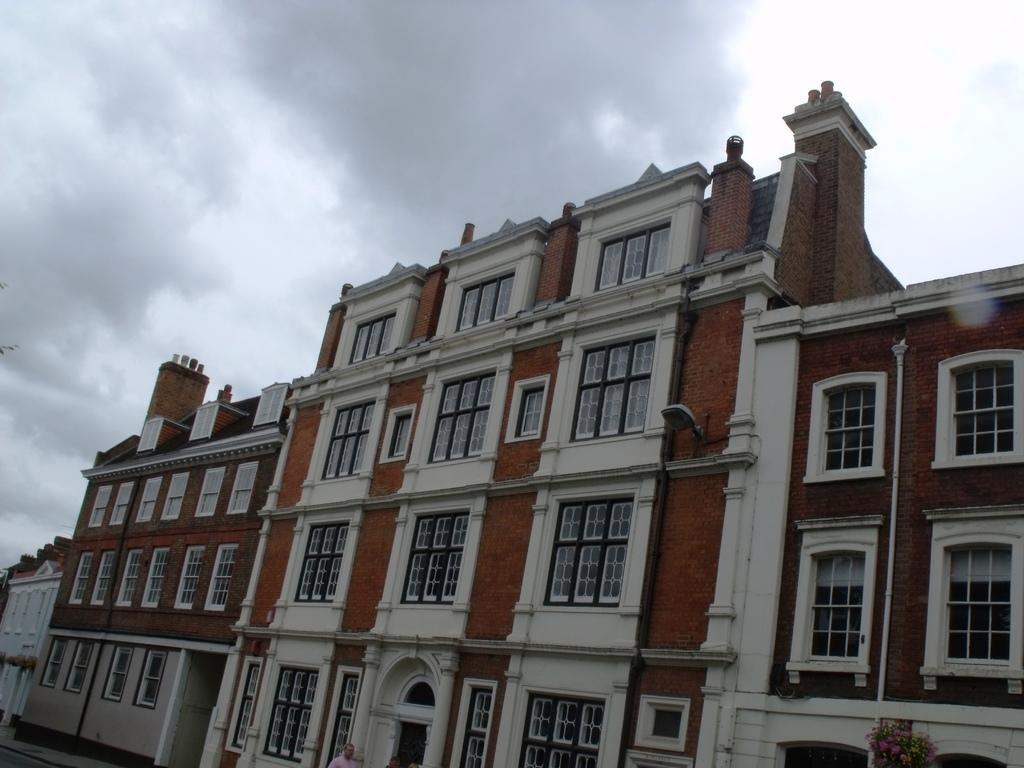What can be seen in the sky in the image? The sky with clouds is visible in the image. What type of structures are present in the image? There are buildings in the image. What part of the buildings can be seen in the image? Windows are present in the image. What infrastructure elements are visible in the image? Pipelines are visible in the image. Who or what is present in the image? There are persons in the image. What type of vegetation is present in the image? Flowers are present in the image. What artificial light source is visible in the image? An electric light is visible in the image. What type of glue is being used by the maid in the image? There is no maid or glue present in the image. What time is displayed on the watch in the image? There is no watch present in the image. 